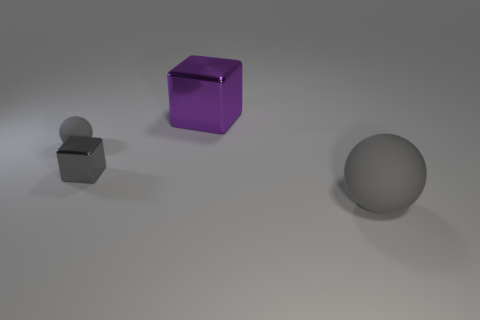What could be the purpose of this arrangement? The arrangement of the objects may serve an aesthetic purpose, such as in a product display or a 3D rendering test. It could also be a setup for a physics demonstration or to test visual perception in terms of size and reflection. 